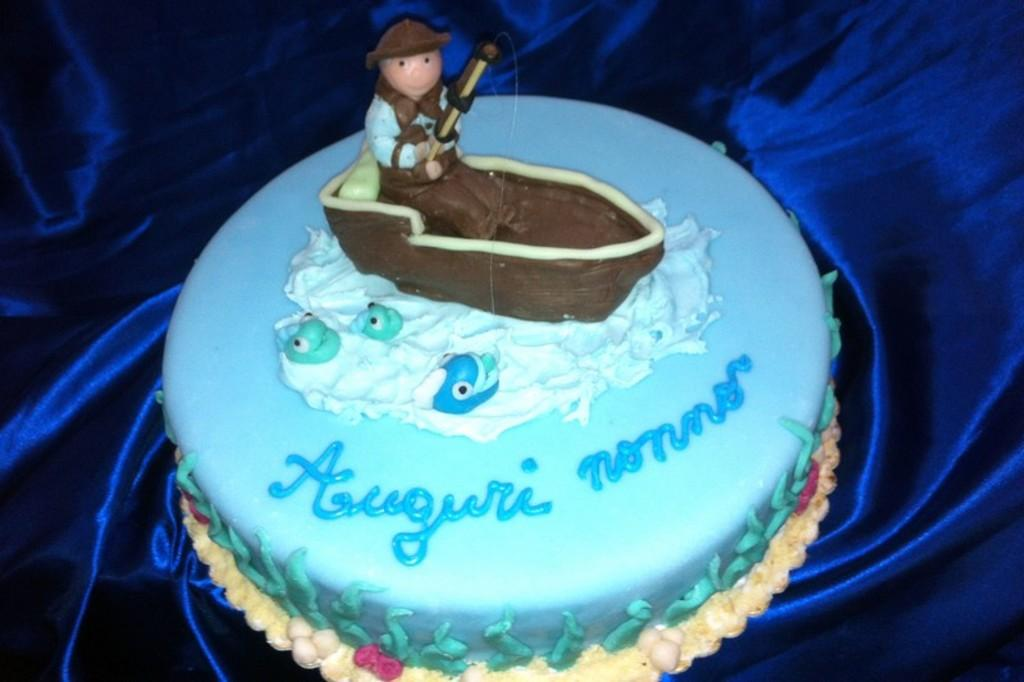What is the main subject of the image? There is a cake in the image. What is the cake placed on? The cake is on a blue color cloth. Is there any text or design on the cake? Yes, there is writing on the cake. Reasoning: Let's think step by step by step in order to produce the conversation. We start by identifying the main subject of the image, which is the cake. Then, we describe the cake's placement, noting that it is on a blue color cloth. Finally, we mention the presence of text on the cake, which adds detail to the image. Absurd Question/Answer: What type of gold jewelry is visible on the cake in the image? There is no gold jewelry present on the cake in the image. What tax rate applies to the cake in the image? There is no information about tax rates in the image, as it only shows a cake with writing on it. 